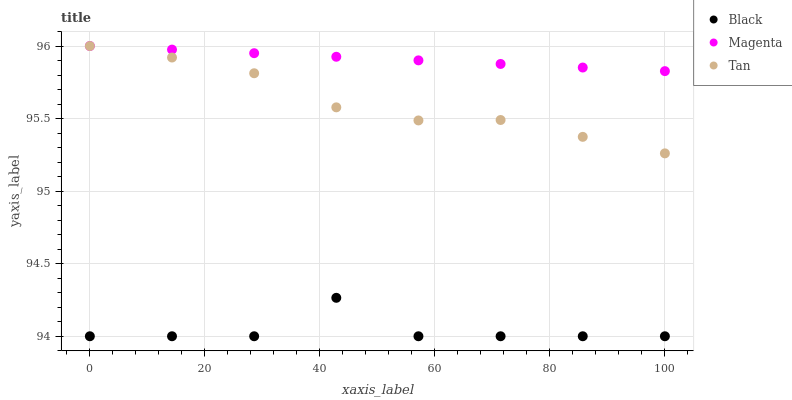Does Black have the minimum area under the curve?
Answer yes or no. Yes. Does Magenta have the maximum area under the curve?
Answer yes or no. Yes. Does Tan have the minimum area under the curve?
Answer yes or no. No. Does Tan have the maximum area under the curve?
Answer yes or no. No. Is Magenta the smoothest?
Answer yes or no. Yes. Is Black the roughest?
Answer yes or no. Yes. Is Tan the smoothest?
Answer yes or no. No. Is Tan the roughest?
Answer yes or no. No. Does Black have the lowest value?
Answer yes or no. Yes. Does Tan have the lowest value?
Answer yes or no. No. Does Tan have the highest value?
Answer yes or no. Yes. Does Black have the highest value?
Answer yes or no. No. Is Black less than Magenta?
Answer yes or no. Yes. Is Tan greater than Black?
Answer yes or no. Yes. Does Tan intersect Magenta?
Answer yes or no. Yes. Is Tan less than Magenta?
Answer yes or no. No. Is Tan greater than Magenta?
Answer yes or no. No. Does Black intersect Magenta?
Answer yes or no. No. 